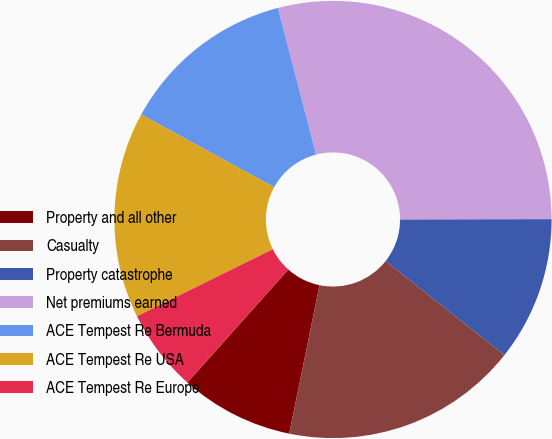<chart> <loc_0><loc_0><loc_500><loc_500><pie_chart><fcel>Property and all other<fcel>Casualty<fcel>Property catastrophe<fcel>Net premiums earned<fcel>ACE Tempest Re Bermuda<fcel>ACE Tempest Re USA<fcel>ACE Tempest Re Europe<nl><fcel>8.39%<fcel>17.56%<fcel>10.68%<fcel>29.03%<fcel>12.98%<fcel>15.27%<fcel>6.1%<nl></chart> 